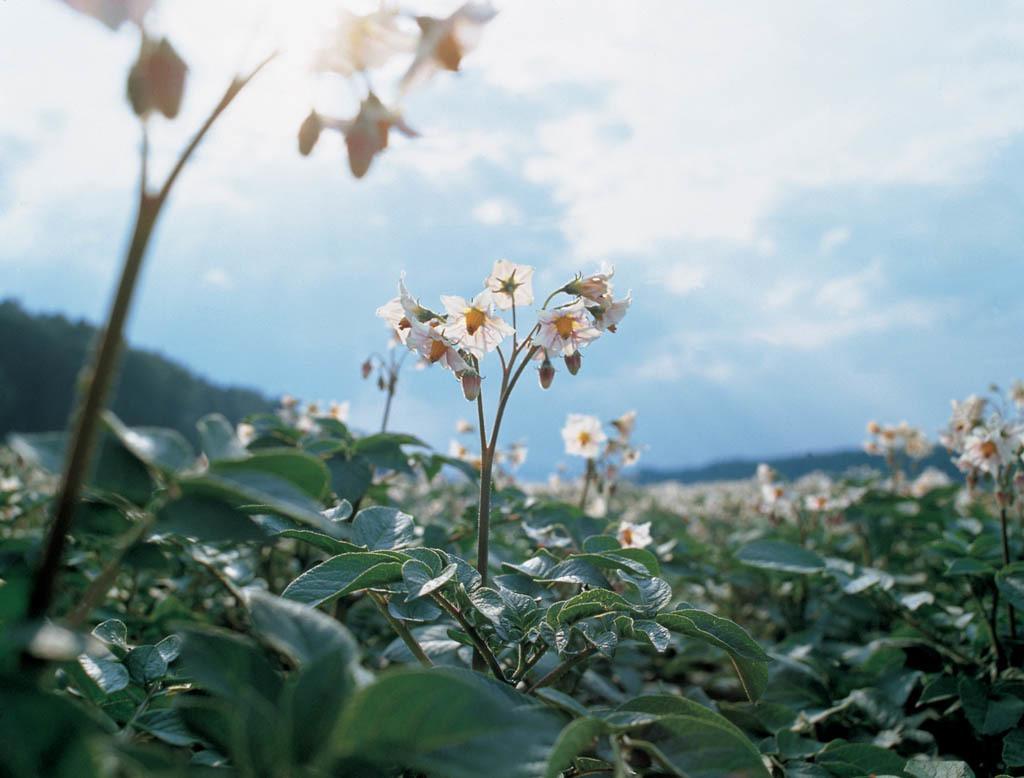Describe this image in one or two sentences. In this image we can see leaves, stems, flowers, and buds. There is a blur background and we can see sky with clouds. 